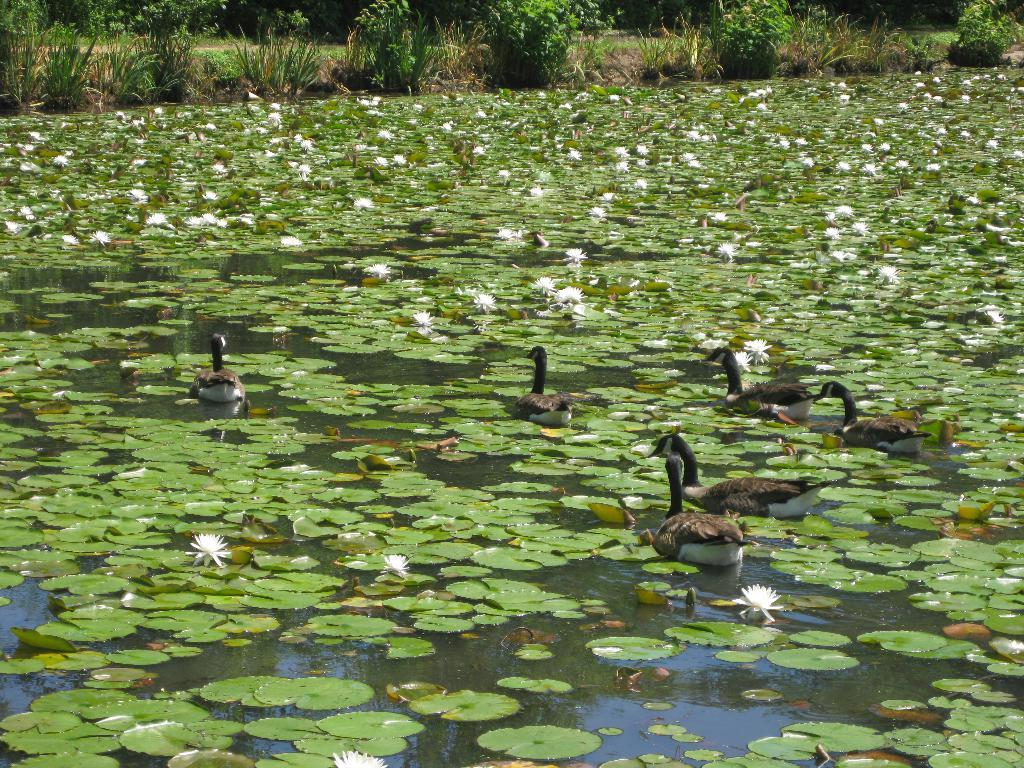What type of plants can be seen in the image? There are flowers and leaves in the image. What is the primary element in which the ducks are situated? The ducks are situated in water. Can you describe the plants on the side of the image? There are plants on the side of the image. What type of pen is being used by the robin in the image? There is no robin or pen present in the image. What type of rail can be seen supporting the plants in the image? There is no rail present in the image; the plants are not supported by any rail. 